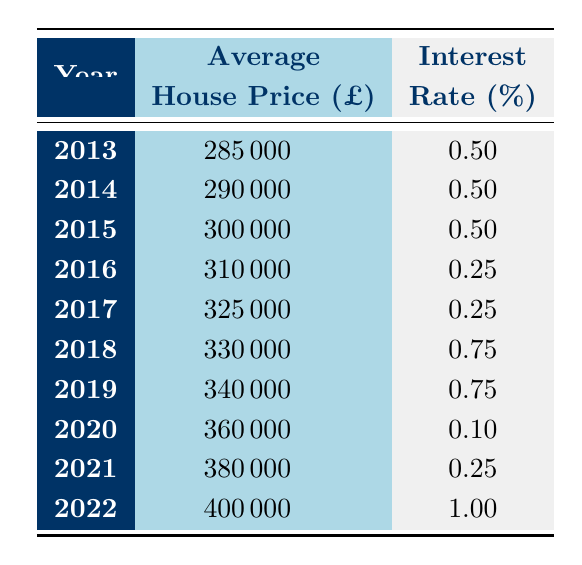What was the average house price in 2016? According to the table, the average house price in 2016 is listed directly as 310000.
Answer: 310000 In which year was the interest rate at its lowest? From the table, the interest rate is lowest in 2020, at 0.10.
Answer: 2020 What was the change in average house price from 2013 to 2022? The average house price in 2013 was 285000 and in 2022 it was 400000. The change is calculated by subtracting 285000 from 400000, which equals 115000.
Answer: 115000 Is there a correlation between rising interest rates and falling house prices? Observing the table, from 2013 to 2019, interest rates were stable or low while house prices increased. In 2022, the interest rate rose, but house prices continued to increase, suggesting no clear correlation.
Answer: No What was the average interest rate for the years 2017 to 2021? The interest rates for these years are 0.25, 0.25, 0.75, 0.10, and 0.25. Adding these values gives 1.50, and dividing by 5 (the number of years) results in an average of 0.30.
Answer: 0.30 Which year saw the highest average house price increase compared to the previous year? Looking at the average house prices between years, the biggest increase from the previous year occurred from 2021 to 2022, where it increased from 380000 to 400000, an increase of 20000.
Answer: 2022 What was the interest rate in 2018, and did it increase or decrease compared to the previous year? The interest rate in 2018 is 0.75. Compared to 2017, which had an interest rate of 0.25, there was an increase of 0.50.
Answer: Increased Which two years had the same interest rate? The interest rates for 2013, 2014, and 2015 were all 0.50, indicating these two years had matching rates.
Answer: 2013 and 2014 